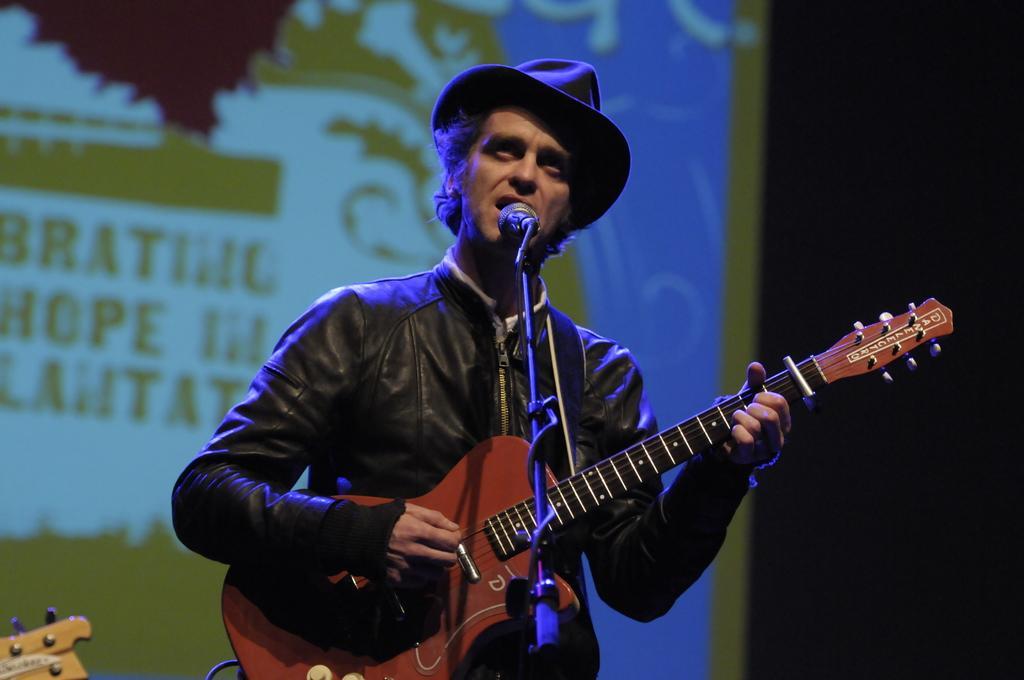Could you give a brief overview of what you see in this image? On the background we can see screen. At the right side of the picture it is completely dark. We can see a man standing in front of a mike wearing a black hat and a jacket, singing and playing guitar. 